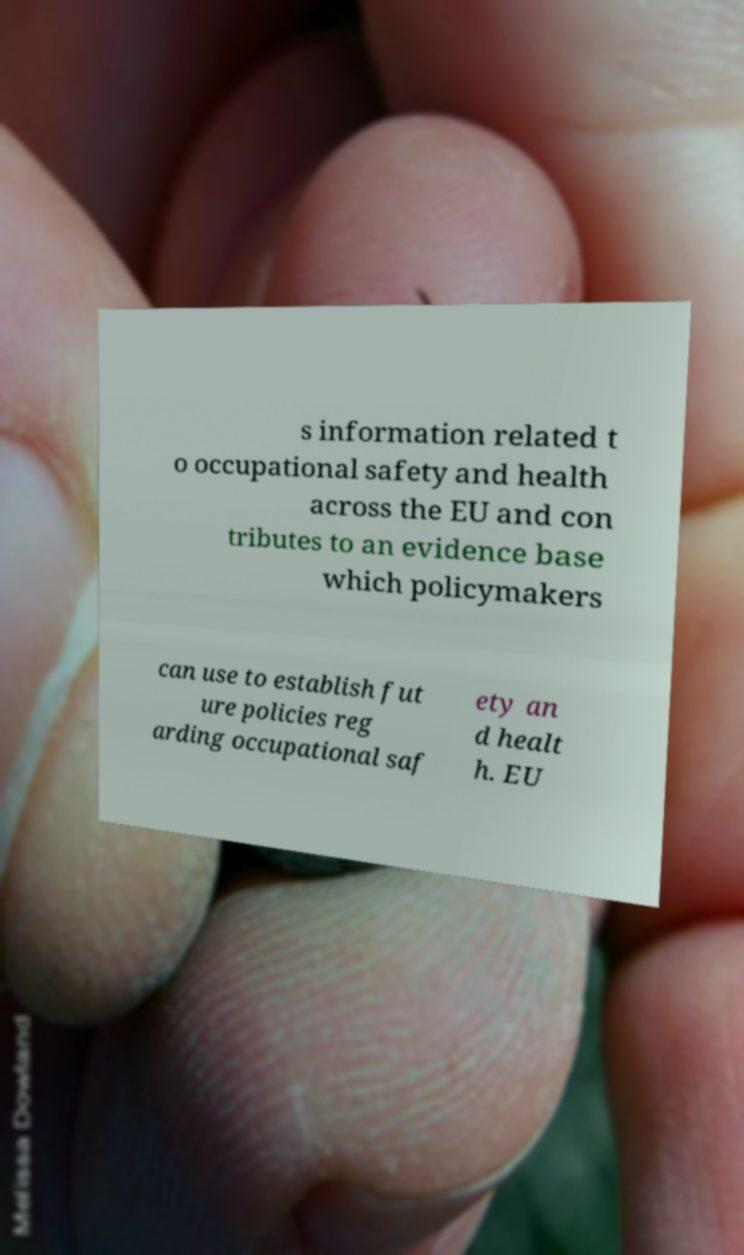What messages or text are displayed in this image? I need them in a readable, typed format. s information related t o occupational safety and health across the EU and con tributes to an evidence base which policymakers can use to establish fut ure policies reg arding occupational saf ety an d healt h. EU 